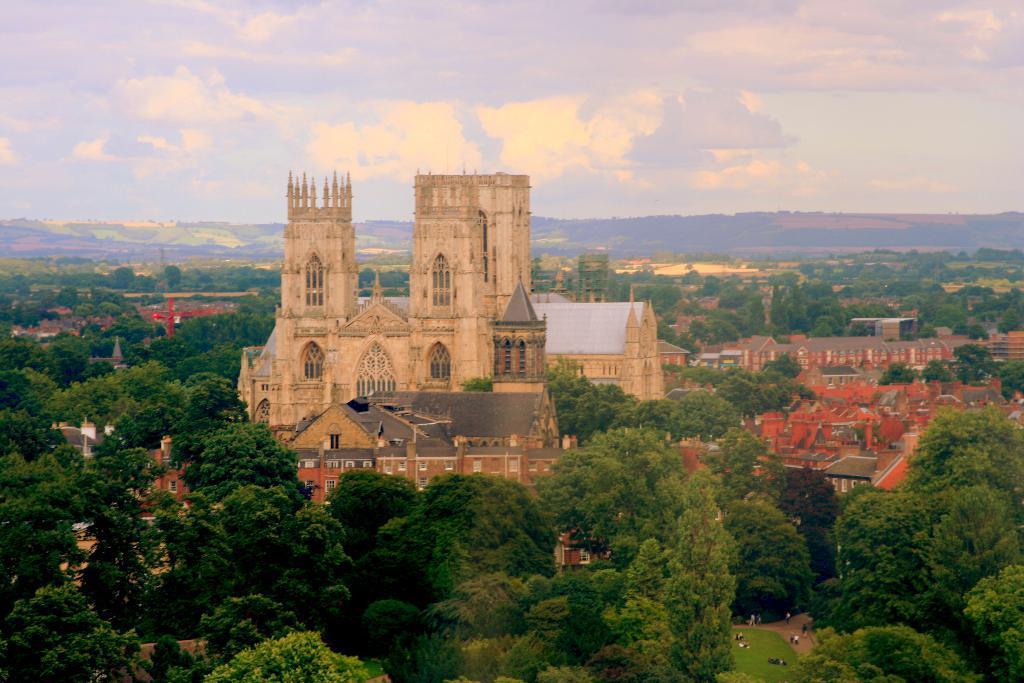In one or two sentences, can you explain what this image depicts? In this image we can see some buildings and houses with roof. We can also see a large group of trees and the grass. On the backside we can see the hills and the sky which looks cloudy. 